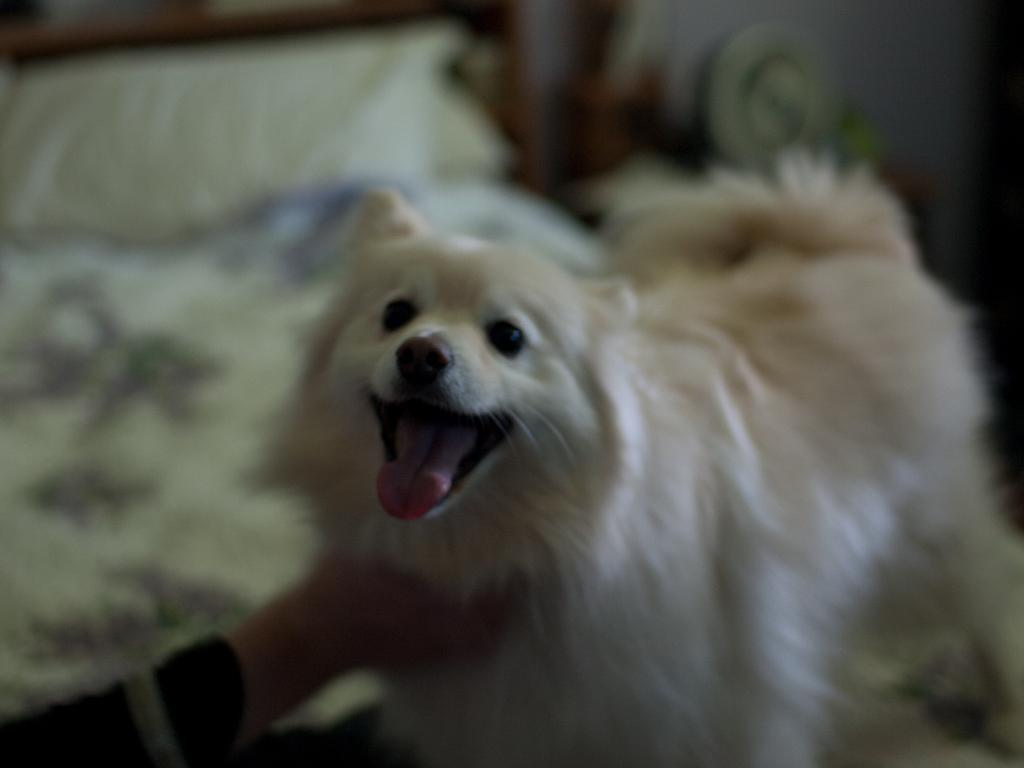What type of animal is in the image? There is a white dog in the image. Can you describe any other elements in the image? There might be a person's hand at the bottom left side of the image. What is visible in the background of the image? There is a bed with a pillow in the background of the image. What songs does the dog hate in the image? There is no information about the dog's musical preferences in the image, so we cannot determine which songs the dog might hate. 